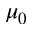Convert formula to latex. <formula><loc_0><loc_0><loc_500><loc_500>\mu _ { 0 }</formula> 